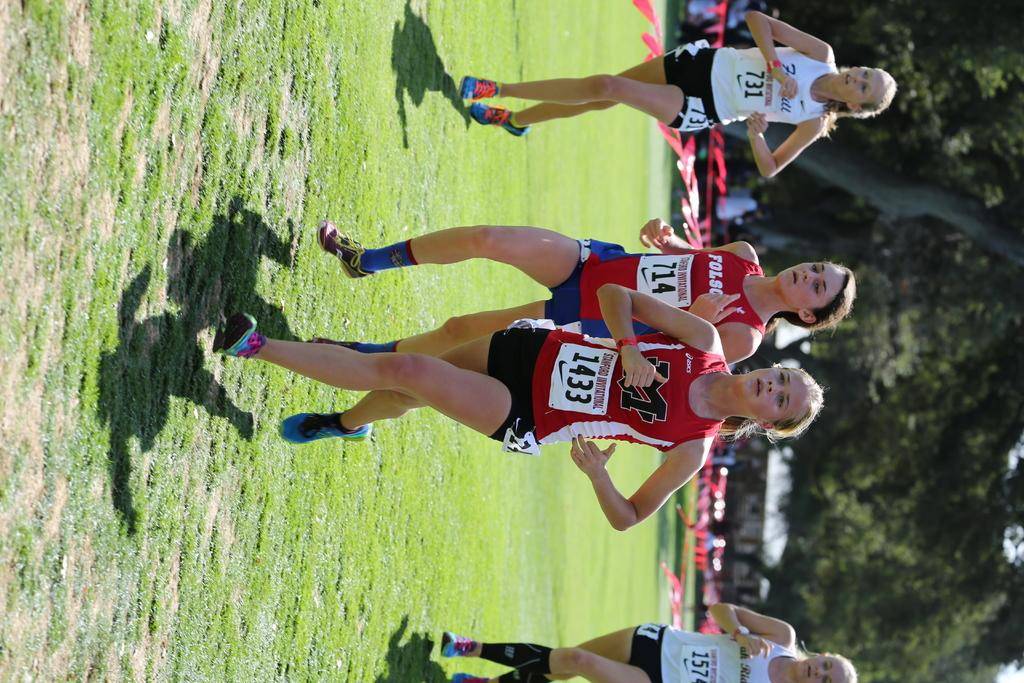What is happening in the image involving the group of people? The people in the image are running. What are the people wearing in the image? The people are wearing red color dress. What can be seen in the background of the image? There are trees in the background of the image, and the grass is green. What is the taste of the memory experienced by the people in the image? There is no mention of memory or taste in the image; the people are simply running and wearing red dresses. 